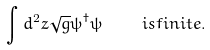<formula> <loc_0><loc_0><loc_500><loc_500>\int d ^ { 2 } z \sqrt { g } \psi ^ { \dagger } \psi \quad \ i s f i n i t e .</formula> 